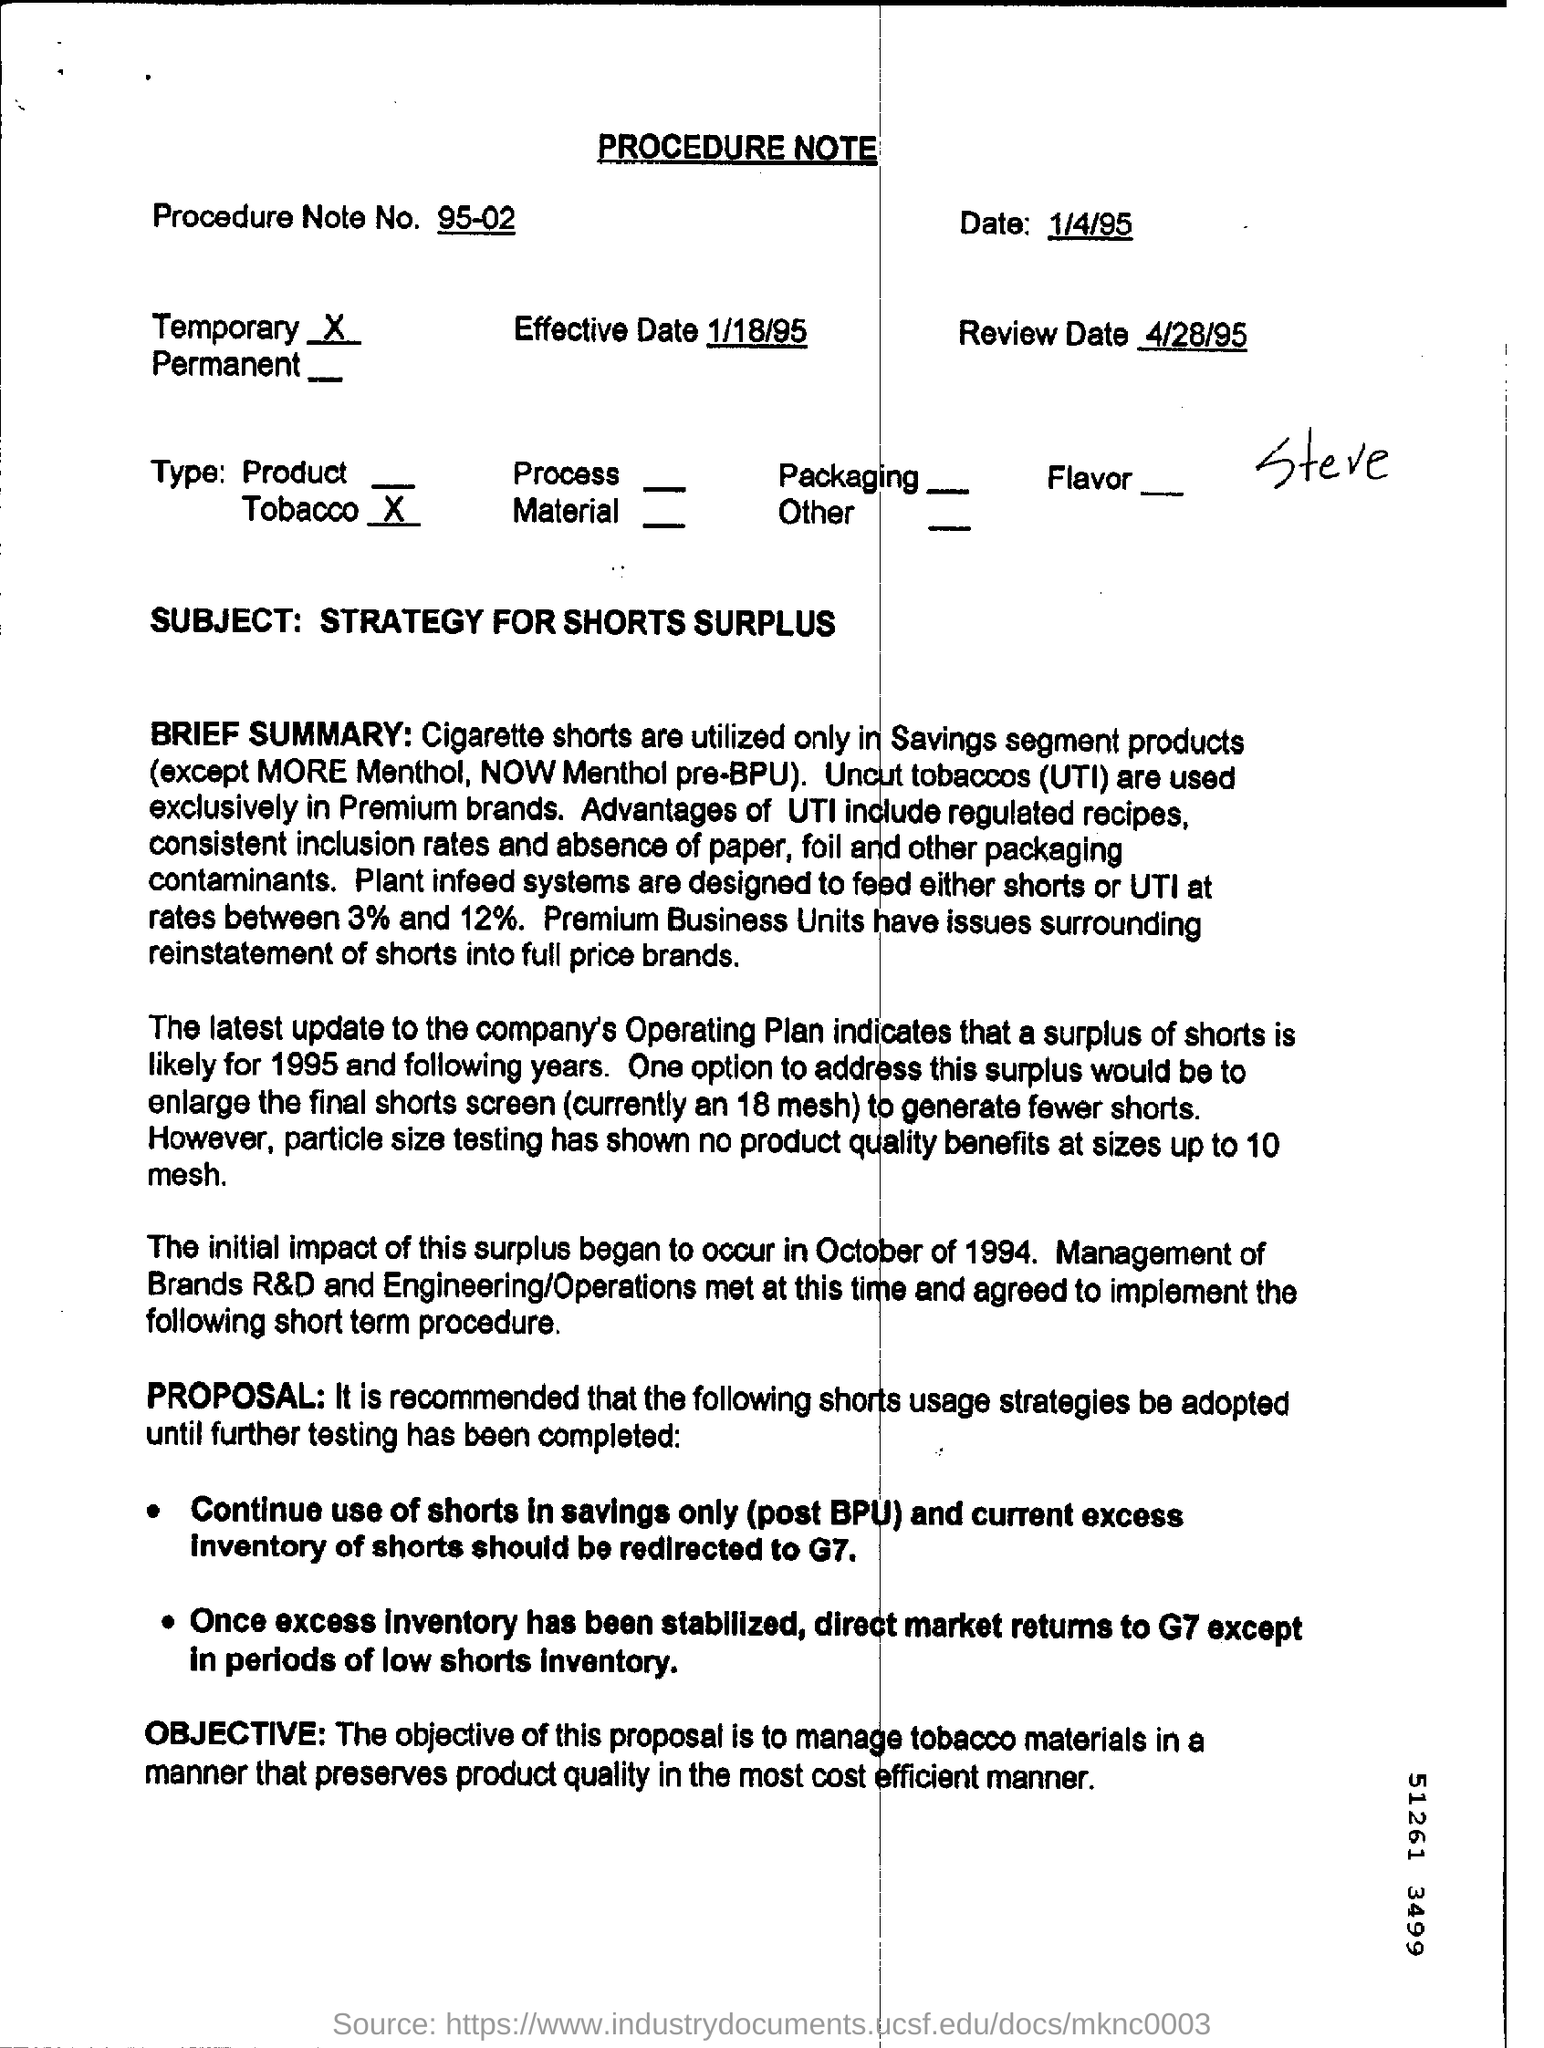What is the Procedure Note No?
 95-02 